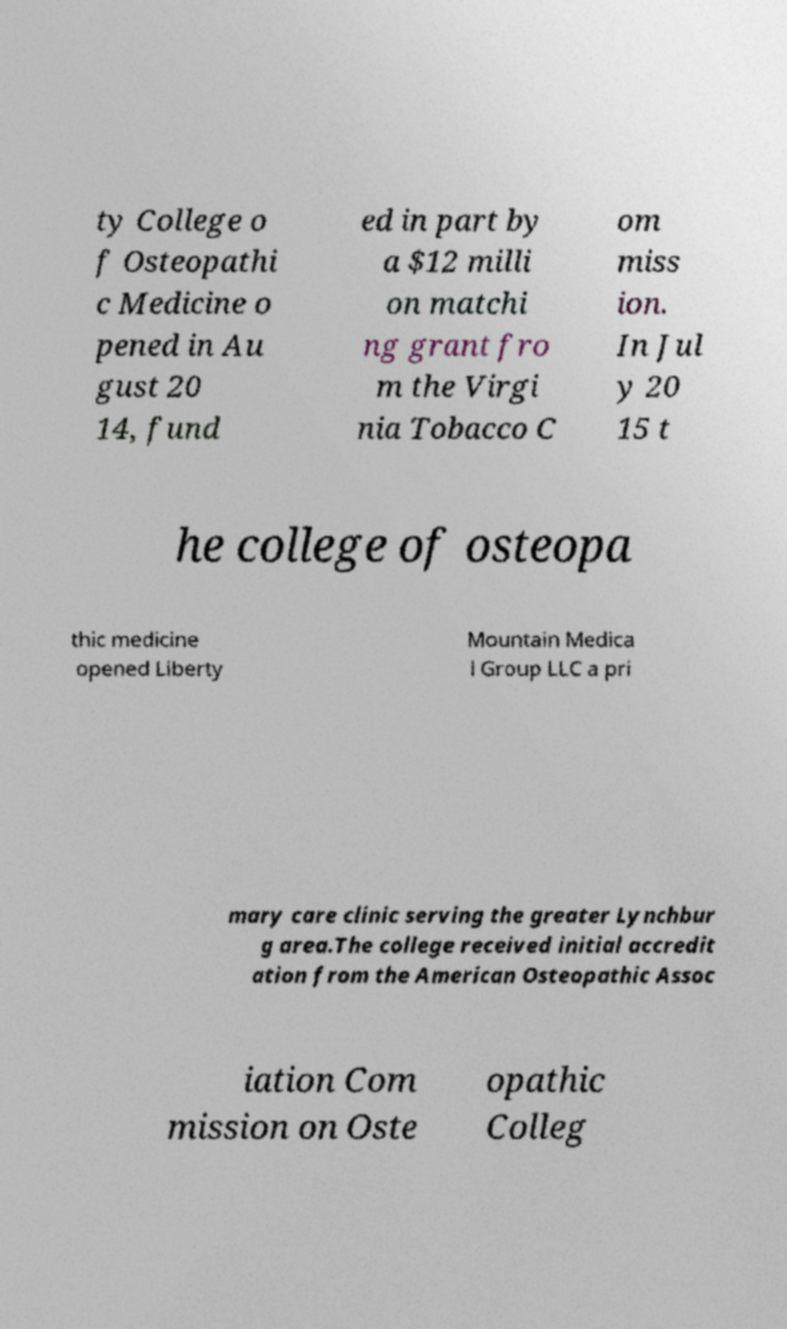For documentation purposes, I need the text within this image transcribed. Could you provide that? ty College o f Osteopathi c Medicine o pened in Au gust 20 14, fund ed in part by a $12 milli on matchi ng grant fro m the Virgi nia Tobacco C om miss ion. In Jul y 20 15 t he college of osteopa thic medicine opened Liberty Mountain Medica l Group LLC a pri mary care clinic serving the greater Lynchbur g area.The college received initial accredit ation from the American Osteopathic Assoc iation Com mission on Oste opathic Colleg 